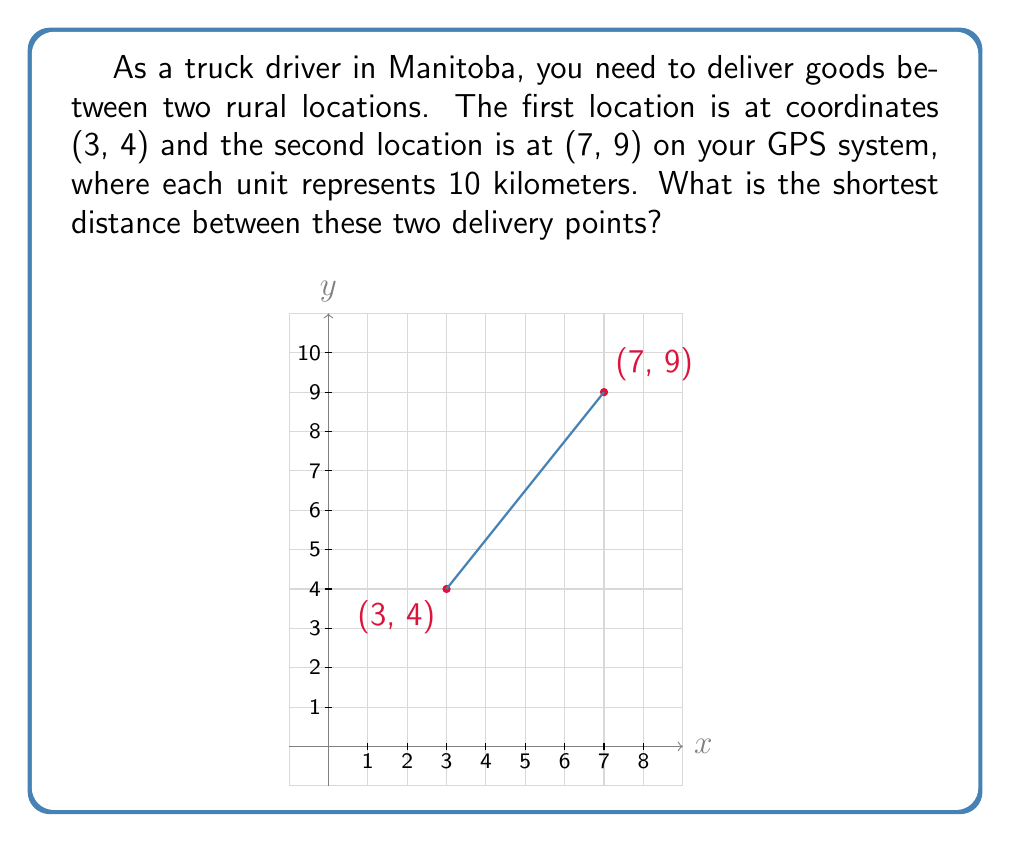Can you solve this math problem? To find the shortest distance between two points in a coordinate system, we can use the distance formula, which is derived from the Pythagorean theorem:

$$d = \sqrt{(x_2 - x_1)^2 + (y_2 - y_1)^2}$$

Where $(x_1, y_1)$ is the first point and $(x_2, y_2)$ is the second point.

Let's plug in our coordinates:
$(x_1, y_1) = (3, 4)$ and $(x_2, y_2) = (7, 9)$

Now, let's calculate step by step:

1) $d = \sqrt{(7 - 3)^2 + (9 - 4)^2}$

2) $d = \sqrt{4^2 + 5^2}$

3) $d = \sqrt{16 + 25}$

4) $d = \sqrt{41}$

5) $d \approx 6.403$ units

Remember that each unit represents 10 kilometers, so we need to multiply our result by 10:

6) $6.403 \times 10 = 64.03$ kilometers

Therefore, the shortest distance between the two delivery points is approximately 64.03 kilometers.
Answer: 64.03 km 